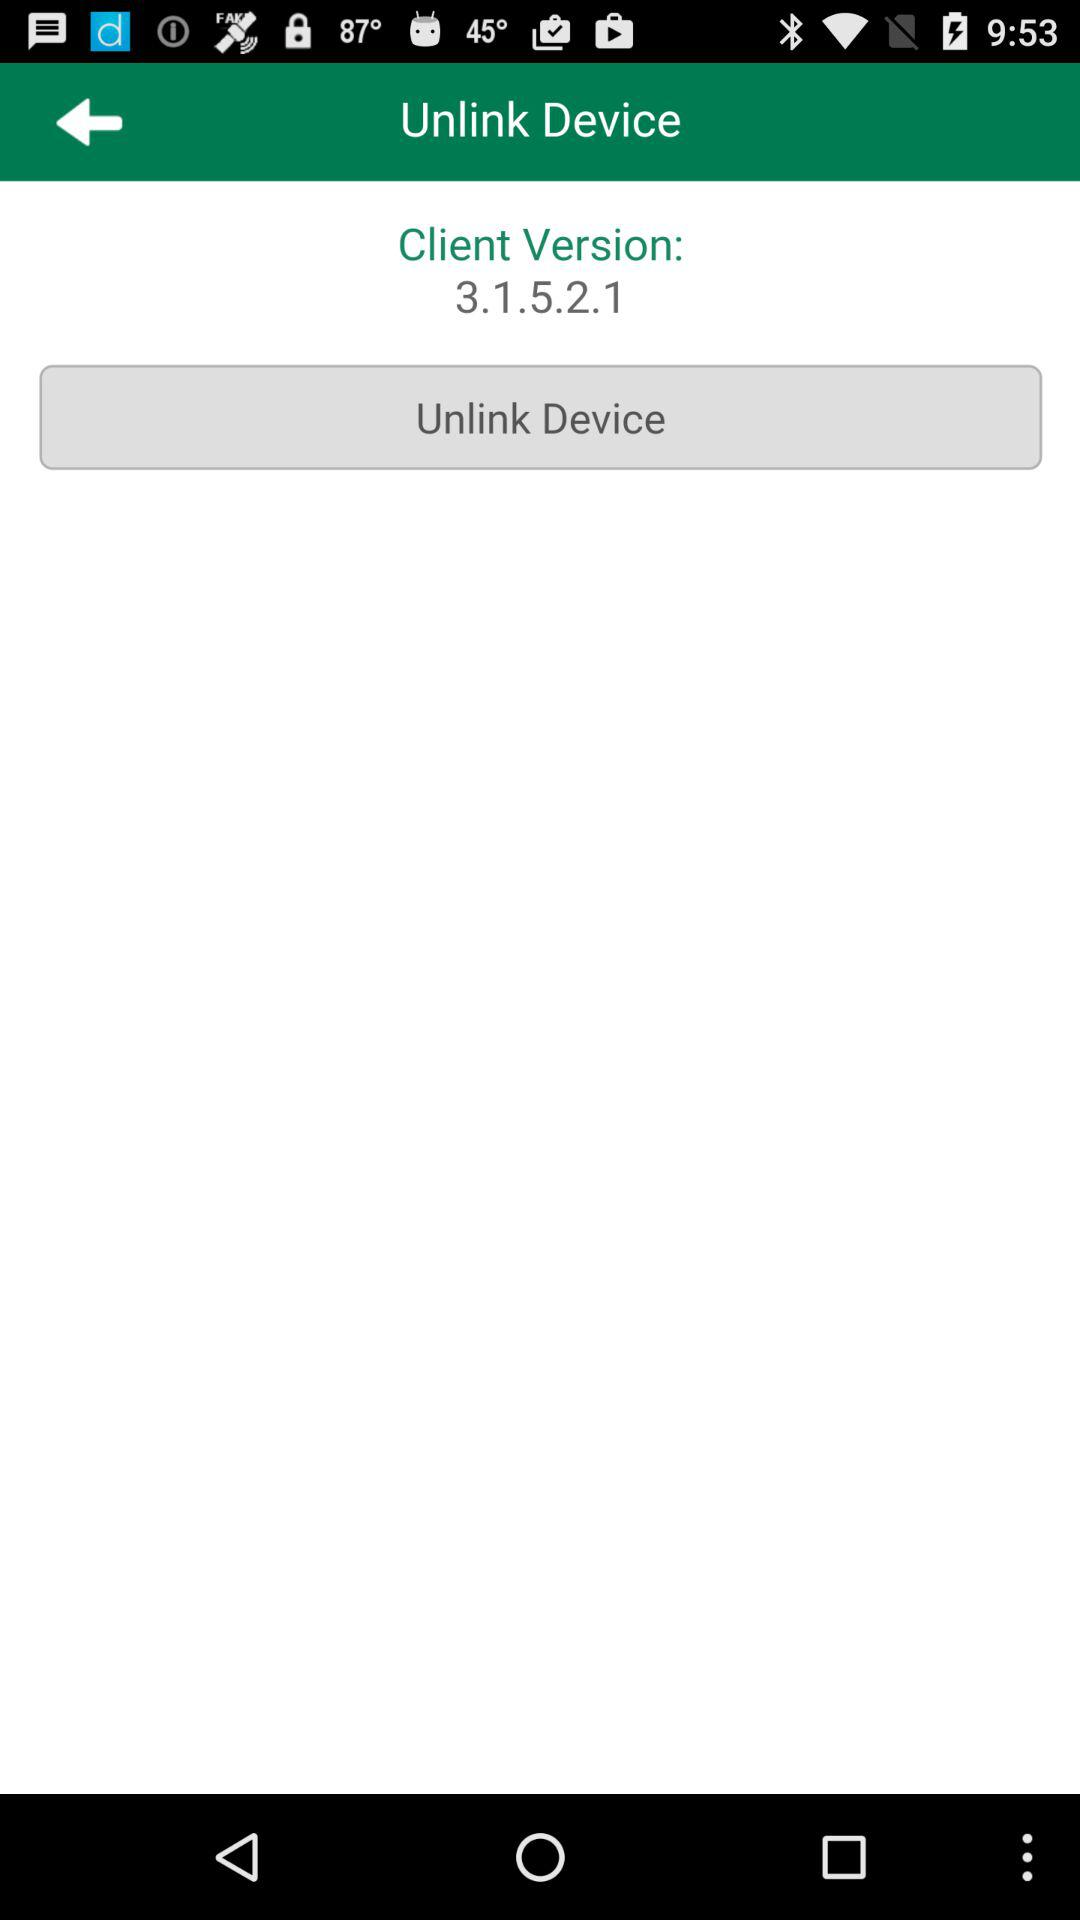What is the client version? The client version is 3.1.5.2.1. 